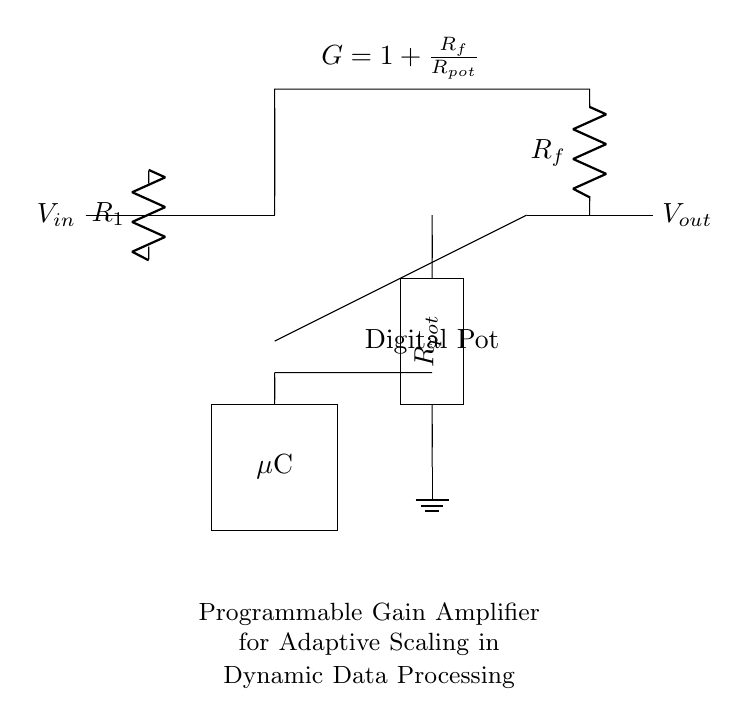What is the input voltage of the circuit? The input voltage is represented by V_in, as indicated at the left side of the circuit diagram.
Answer: V_in What type of amplifier is shown in the circuit? The circuit is a Programmable Gain Amplifier, which is specified in the explanation within the circuit diagram.
Answer: Programmable Gain Amplifier What is the gain formula provided in the circuit? The gain formula is stated as G = 1 + R_f/R_pot, where R_f is the feedback resistor and R_pot is the resistance of the digital potentiometer.
Answer: G = 1 + R_f/R_pot What component is marked as the digital potentiometer? The component labeled as "Digital Pot" is indicated by a rectangle at the bottom part of the circuit, showing its function in adjusting gain.
Answer: Digital Pot How does the microcontroller interact with the circuit? The microcontroller connects to the digital potentiometer and influences the gain by adjusting its resistance, which is connected to the op-amp.
Answer: Adjusts gain What does the feedback resistor do in this amplifier circuit? The feedback resistor, designated as R_f, plays a critical role in determining the gain of the amplifier by setting the feedback loop with the input signal.
Answer: Determines gain What is the output voltage of the amplifier? The output voltage is represented by V_out, positioned on the right side of the circuit diagram, showing the amplified result.
Answer: V_out 